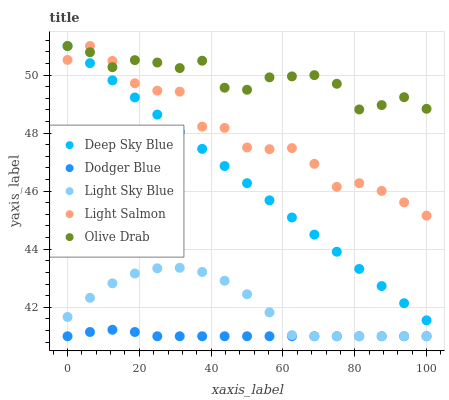Does Dodger Blue have the minimum area under the curve?
Answer yes or no. Yes. Does Olive Drab have the maximum area under the curve?
Answer yes or no. Yes. Does Light Sky Blue have the minimum area under the curve?
Answer yes or no. No. Does Light Sky Blue have the maximum area under the curve?
Answer yes or no. No. Is Deep Sky Blue the smoothest?
Answer yes or no. Yes. Is Light Salmon the roughest?
Answer yes or no. Yes. Is Light Sky Blue the smoothest?
Answer yes or no. No. Is Light Sky Blue the roughest?
Answer yes or no. No. Does Light Sky Blue have the lowest value?
Answer yes or no. Yes. Does Olive Drab have the lowest value?
Answer yes or no. No. Does Deep Sky Blue have the highest value?
Answer yes or no. Yes. Does Light Sky Blue have the highest value?
Answer yes or no. No. Is Dodger Blue less than Deep Sky Blue?
Answer yes or no. Yes. Is Deep Sky Blue greater than Dodger Blue?
Answer yes or no. Yes. Does Light Salmon intersect Olive Drab?
Answer yes or no. Yes. Is Light Salmon less than Olive Drab?
Answer yes or no. No. Is Light Salmon greater than Olive Drab?
Answer yes or no. No. Does Dodger Blue intersect Deep Sky Blue?
Answer yes or no. No. 